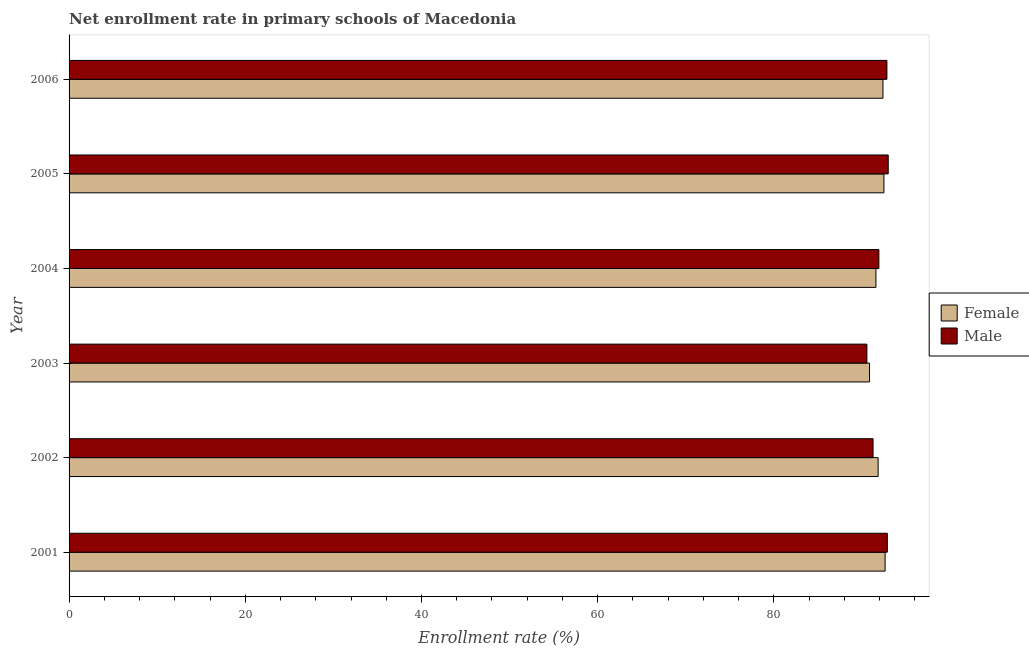How many different coloured bars are there?
Your answer should be very brief. 2. How many groups of bars are there?
Make the answer very short. 6. Are the number of bars per tick equal to the number of legend labels?
Offer a terse response. Yes. What is the label of the 5th group of bars from the top?
Give a very brief answer. 2002. In how many cases, is the number of bars for a given year not equal to the number of legend labels?
Ensure brevity in your answer.  0. What is the enrollment rate of male students in 2001?
Offer a very short reply. 92.88. Across all years, what is the maximum enrollment rate of male students?
Ensure brevity in your answer.  92.98. Across all years, what is the minimum enrollment rate of female students?
Keep it short and to the point. 90.86. In which year was the enrollment rate of male students minimum?
Offer a terse response. 2003. What is the total enrollment rate of male students in the graph?
Offer a very short reply. 552.42. What is the difference between the enrollment rate of female students in 2002 and that in 2005?
Provide a succinct answer. -0.66. What is the difference between the enrollment rate of female students in 2003 and the enrollment rate of male students in 2006?
Your response must be concise. -1.97. What is the average enrollment rate of female students per year?
Your response must be concise. 91.96. In the year 2004, what is the difference between the enrollment rate of male students and enrollment rate of female students?
Your response must be concise. 0.33. In how many years, is the enrollment rate of male students greater than 48 %?
Your answer should be very brief. 6. What is the ratio of the enrollment rate of male students in 2003 to that in 2005?
Offer a terse response. 0.97. What is the difference between the highest and the second highest enrollment rate of male students?
Offer a very short reply. 0.1. What is the difference between the highest and the lowest enrollment rate of male students?
Offer a terse response. 2.42. Is the sum of the enrollment rate of male students in 2001 and 2003 greater than the maximum enrollment rate of female students across all years?
Offer a very short reply. Yes. How many bars are there?
Your response must be concise. 12. Are all the bars in the graph horizontal?
Make the answer very short. Yes. How many years are there in the graph?
Offer a terse response. 6. Does the graph contain any zero values?
Keep it short and to the point. No. How are the legend labels stacked?
Keep it short and to the point. Vertical. What is the title of the graph?
Your response must be concise. Net enrollment rate in primary schools of Macedonia. What is the label or title of the X-axis?
Make the answer very short. Enrollment rate (%). What is the Enrollment rate (%) in Female in 2001?
Give a very brief answer. 92.62. What is the Enrollment rate (%) of Male in 2001?
Your response must be concise. 92.88. What is the Enrollment rate (%) of Female in 2002?
Offer a very short reply. 91.83. What is the Enrollment rate (%) of Male in 2002?
Ensure brevity in your answer.  91.26. What is the Enrollment rate (%) of Female in 2003?
Make the answer very short. 90.86. What is the Enrollment rate (%) of Male in 2003?
Keep it short and to the point. 90.56. What is the Enrollment rate (%) in Female in 2004?
Your answer should be compact. 91.58. What is the Enrollment rate (%) of Male in 2004?
Offer a terse response. 91.92. What is the Enrollment rate (%) of Female in 2005?
Ensure brevity in your answer.  92.49. What is the Enrollment rate (%) in Male in 2005?
Provide a short and direct response. 92.98. What is the Enrollment rate (%) of Female in 2006?
Provide a short and direct response. 92.38. What is the Enrollment rate (%) in Male in 2006?
Give a very brief answer. 92.83. Across all years, what is the maximum Enrollment rate (%) of Female?
Provide a succinct answer. 92.62. Across all years, what is the maximum Enrollment rate (%) in Male?
Make the answer very short. 92.98. Across all years, what is the minimum Enrollment rate (%) in Female?
Make the answer very short. 90.86. Across all years, what is the minimum Enrollment rate (%) of Male?
Offer a very short reply. 90.56. What is the total Enrollment rate (%) of Female in the graph?
Your answer should be compact. 551.77. What is the total Enrollment rate (%) in Male in the graph?
Make the answer very short. 552.42. What is the difference between the Enrollment rate (%) in Female in 2001 and that in 2002?
Provide a short and direct response. 0.79. What is the difference between the Enrollment rate (%) in Male in 2001 and that in 2002?
Provide a short and direct response. 1.62. What is the difference between the Enrollment rate (%) in Female in 2001 and that in 2003?
Offer a terse response. 1.77. What is the difference between the Enrollment rate (%) in Male in 2001 and that in 2003?
Your answer should be very brief. 2.32. What is the difference between the Enrollment rate (%) in Female in 2001 and that in 2004?
Keep it short and to the point. 1.04. What is the difference between the Enrollment rate (%) in Male in 2001 and that in 2004?
Your answer should be very brief. 0.96. What is the difference between the Enrollment rate (%) in Female in 2001 and that in 2005?
Give a very brief answer. 0.13. What is the difference between the Enrollment rate (%) in Male in 2001 and that in 2005?
Provide a short and direct response. -0.1. What is the difference between the Enrollment rate (%) in Female in 2001 and that in 2006?
Ensure brevity in your answer.  0.25. What is the difference between the Enrollment rate (%) of Male in 2001 and that in 2006?
Provide a short and direct response. 0.05. What is the difference between the Enrollment rate (%) of Female in 2002 and that in 2003?
Your answer should be very brief. 0.97. What is the difference between the Enrollment rate (%) of Male in 2002 and that in 2003?
Ensure brevity in your answer.  0.7. What is the difference between the Enrollment rate (%) in Female in 2002 and that in 2004?
Offer a very short reply. 0.25. What is the difference between the Enrollment rate (%) in Male in 2002 and that in 2004?
Make the answer very short. -0.66. What is the difference between the Enrollment rate (%) of Female in 2002 and that in 2005?
Ensure brevity in your answer.  -0.66. What is the difference between the Enrollment rate (%) of Male in 2002 and that in 2005?
Ensure brevity in your answer.  -1.72. What is the difference between the Enrollment rate (%) of Female in 2002 and that in 2006?
Give a very brief answer. -0.55. What is the difference between the Enrollment rate (%) in Male in 2002 and that in 2006?
Offer a very short reply. -1.57. What is the difference between the Enrollment rate (%) of Female in 2003 and that in 2004?
Keep it short and to the point. -0.73. What is the difference between the Enrollment rate (%) in Male in 2003 and that in 2004?
Ensure brevity in your answer.  -1.36. What is the difference between the Enrollment rate (%) in Female in 2003 and that in 2005?
Give a very brief answer. -1.63. What is the difference between the Enrollment rate (%) in Male in 2003 and that in 2005?
Your response must be concise. -2.42. What is the difference between the Enrollment rate (%) in Female in 2003 and that in 2006?
Make the answer very short. -1.52. What is the difference between the Enrollment rate (%) in Male in 2003 and that in 2006?
Offer a terse response. -2.27. What is the difference between the Enrollment rate (%) in Female in 2004 and that in 2005?
Provide a short and direct response. -0.91. What is the difference between the Enrollment rate (%) in Male in 2004 and that in 2005?
Provide a succinct answer. -1.06. What is the difference between the Enrollment rate (%) in Female in 2004 and that in 2006?
Provide a succinct answer. -0.79. What is the difference between the Enrollment rate (%) of Male in 2004 and that in 2006?
Your answer should be compact. -0.91. What is the difference between the Enrollment rate (%) of Female in 2005 and that in 2006?
Your answer should be compact. 0.11. What is the difference between the Enrollment rate (%) in Male in 2005 and that in 2006?
Your answer should be very brief. 0.15. What is the difference between the Enrollment rate (%) in Female in 2001 and the Enrollment rate (%) in Male in 2002?
Your answer should be compact. 1.37. What is the difference between the Enrollment rate (%) in Female in 2001 and the Enrollment rate (%) in Male in 2003?
Keep it short and to the point. 2.07. What is the difference between the Enrollment rate (%) in Female in 2001 and the Enrollment rate (%) in Male in 2004?
Give a very brief answer. 0.71. What is the difference between the Enrollment rate (%) in Female in 2001 and the Enrollment rate (%) in Male in 2005?
Ensure brevity in your answer.  -0.36. What is the difference between the Enrollment rate (%) in Female in 2001 and the Enrollment rate (%) in Male in 2006?
Provide a short and direct response. -0.2. What is the difference between the Enrollment rate (%) in Female in 2002 and the Enrollment rate (%) in Male in 2003?
Ensure brevity in your answer.  1.27. What is the difference between the Enrollment rate (%) of Female in 2002 and the Enrollment rate (%) of Male in 2004?
Provide a succinct answer. -0.08. What is the difference between the Enrollment rate (%) of Female in 2002 and the Enrollment rate (%) of Male in 2005?
Keep it short and to the point. -1.15. What is the difference between the Enrollment rate (%) in Female in 2002 and the Enrollment rate (%) in Male in 2006?
Your response must be concise. -1. What is the difference between the Enrollment rate (%) of Female in 2003 and the Enrollment rate (%) of Male in 2004?
Make the answer very short. -1.06. What is the difference between the Enrollment rate (%) in Female in 2003 and the Enrollment rate (%) in Male in 2005?
Offer a very short reply. -2.12. What is the difference between the Enrollment rate (%) in Female in 2003 and the Enrollment rate (%) in Male in 2006?
Provide a succinct answer. -1.97. What is the difference between the Enrollment rate (%) of Female in 2004 and the Enrollment rate (%) of Male in 2005?
Keep it short and to the point. -1.4. What is the difference between the Enrollment rate (%) in Female in 2004 and the Enrollment rate (%) in Male in 2006?
Your answer should be compact. -1.25. What is the difference between the Enrollment rate (%) in Female in 2005 and the Enrollment rate (%) in Male in 2006?
Give a very brief answer. -0.34. What is the average Enrollment rate (%) of Female per year?
Give a very brief answer. 91.96. What is the average Enrollment rate (%) of Male per year?
Ensure brevity in your answer.  92.07. In the year 2001, what is the difference between the Enrollment rate (%) in Female and Enrollment rate (%) in Male?
Your response must be concise. -0.25. In the year 2002, what is the difference between the Enrollment rate (%) of Female and Enrollment rate (%) of Male?
Make the answer very short. 0.57. In the year 2003, what is the difference between the Enrollment rate (%) in Female and Enrollment rate (%) in Male?
Offer a very short reply. 0.3. In the year 2004, what is the difference between the Enrollment rate (%) in Female and Enrollment rate (%) in Male?
Your answer should be very brief. -0.33. In the year 2005, what is the difference between the Enrollment rate (%) of Female and Enrollment rate (%) of Male?
Provide a succinct answer. -0.49. In the year 2006, what is the difference between the Enrollment rate (%) in Female and Enrollment rate (%) in Male?
Your answer should be compact. -0.45. What is the ratio of the Enrollment rate (%) in Female in 2001 to that in 2002?
Offer a very short reply. 1.01. What is the ratio of the Enrollment rate (%) of Male in 2001 to that in 2002?
Ensure brevity in your answer.  1.02. What is the ratio of the Enrollment rate (%) of Female in 2001 to that in 2003?
Provide a short and direct response. 1.02. What is the ratio of the Enrollment rate (%) of Male in 2001 to that in 2003?
Ensure brevity in your answer.  1.03. What is the ratio of the Enrollment rate (%) of Female in 2001 to that in 2004?
Make the answer very short. 1.01. What is the ratio of the Enrollment rate (%) in Male in 2001 to that in 2004?
Provide a succinct answer. 1.01. What is the ratio of the Enrollment rate (%) in Female in 2001 to that in 2005?
Offer a terse response. 1. What is the ratio of the Enrollment rate (%) in Female in 2002 to that in 2003?
Provide a succinct answer. 1.01. What is the ratio of the Enrollment rate (%) of Male in 2002 to that in 2003?
Your response must be concise. 1.01. What is the ratio of the Enrollment rate (%) of Female in 2002 to that in 2005?
Offer a terse response. 0.99. What is the ratio of the Enrollment rate (%) in Male in 2002 to that in 2005?
Provide a short and direct response. 0.98. What is the ratio of the Enrollment rate (%) of Female in 2002 to that in 2006?
Keep it short and to the point. 0.99. What is the ratio of the Enrollment rate (%) in Male in 2002 to that in 2006?
Offer a very short reply. 0.98. What is the ratio of the Enrollment rate (%) of Male in 2003 to that in 2004?
Offer a very short reply. 0.99. What is the ratio of the Enrollment rate (%) in Female in 2003 to that in 2005?
Your answer should be very brief. 0.98. What is the ratio of the Enrollment rate (%) in Male in 2003 to that in 2005?
Provide a succinct answer. 0.97. What is the ratio of the Enrollment rate (%) of Female in 2003 to that in 2006?
Offer a terse response. 0.98. What is the ratio of the Enrollment rate (%) of Male in 2003 to that in 2006?
Provide a short and direct response. 0.98. What is the ratio of the Enrollment rate (%) of Female in 2004 to that in 2005?
Make the answer very short. 0.99. What is the ratio of the Enrollment rate (%) of Male in 2004 to that in 2006?
Provide a short and direct response. 0.99. What is the ratio of the Enrollment rate (%) in Male in 2005 to that in 2006?
Keep it short and to the point. 1. What is the difference between the highest and the second highest Enrollment rate (%) in Female?
Keep it short and to the point. 0.13. What is the difference between the highest and the second highest Enrollment rate (%) of Male?
Your answer should be compact. 0.1. What is the difference between the highest and the lowest Enrollment rate (%) in Female?
Keep it short and to the point. 1.77. What is the difference between the highest and the lowest Enrollment rate (%) in Male?
Your answer should be compact. 2.42. 